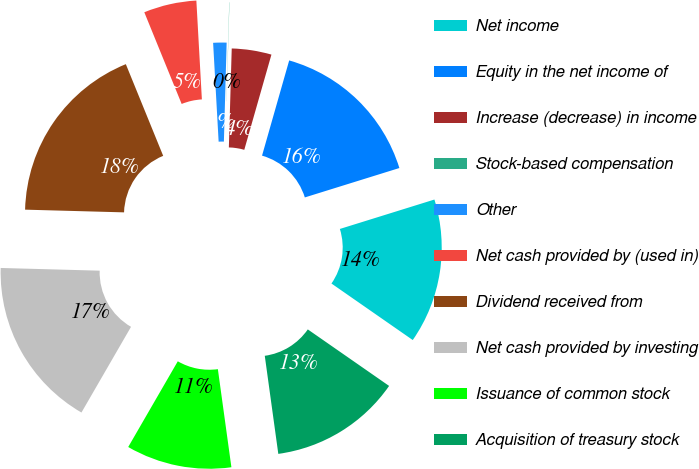Convert chart to OTSL. <chart><loc_0><loc_0><loc_500><loc_500><pie_chart><fcel>Net income<fcel>Equity in the net income of<fcel>Increase (decrease) in income<fcel>Stock-based compensation<fcel>Other<fcel>Net cash provided by (used in)<fcel>Dividend received from<fcel>Net cash provided by investing<fcel>Issuance of common stock<fcel>Acquisition of treasury stock<nl><fcel>14.47%<fcel>15.78%<fcel>3.96%<fcel>0.02%<fcel>1.33%<fcel>5.27%<fcel>18.41%<fcel>17.09%<fcel>10.53%<fcel>13.15%<nl></chart> 